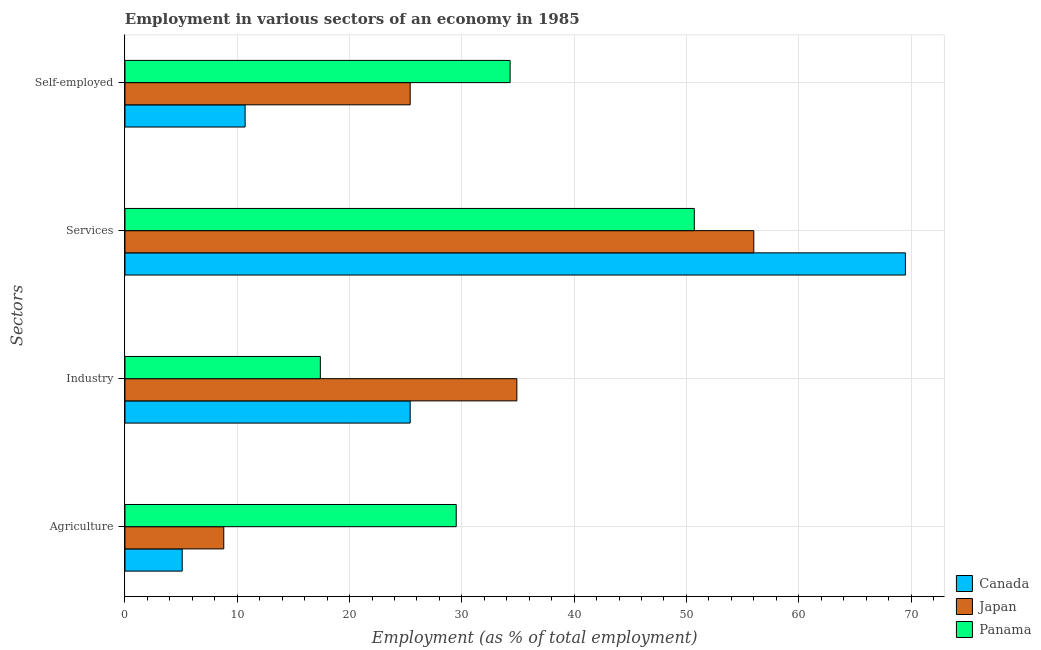How many different coloured bars are there?
Offer a terse response. 3. How many groups of bars are there?
Your response must be concise. 4. How many bars are there on the 1st tick from the bottom?
Offer a terse response. 3. What is the label of the 2nd group of bars from the top?
Give a very brief answer. Services. What is the percentage of self employed workers in Japan?
Give a very brief answer. 25.4. Across all countries, what is the maximum percentage of self employed workers?
Your answer should be very brief. 34.3. Across all countries, what is the minimum percentage of self employed workers?
Provide a succinct answer. 10.7. In which country was the percentage of workers in services maximum?
Make the answer very short. Canada. In which country was the percentage of workers in services minimum?
Keep it short and to the point. Panama. What is the total percentage of workers in industry in the graph?
Keep it short and to the point. 77.7. What is the difference between the percentage of workers in industry in Panama and that in Japan?
Keep it short and to the point. -17.5. What is the difference between the percentage of workers in agriculture in Canada and the percentage of self employed workers in Japan?
Offer a very short reply. -20.3. What is the average percentage of workers in industry per country?
Give a very brief answer. 25.9. What is the difference between the percentage of workers in services and percentage of workers in industry in Japan?
Provide a succinct answer. 21.1. What is the ratio of the percentage of self employed workers in Canada to that in Japan?
Make the answer very short. 0.42. What is the difference between the highest and the second highest percentage of self employed workers?
Keep it short and to the point. 8.9. What is the difference between the highest and the lowest percentage of workers in agriculture?
Ensure brevity in your answer.  24.4. In how many countries, is the percentage of self employed workers greater than the average percentage of self employed workers taken over all countries?
Provide a succinct answer. 2. Is the sum of the percentage of workers in agriculture in Canada and Japan greater than the maximum percentage of workers in services across all countries?
Your answer should be very brief. No. How many bars are there?
Provide a succinct answer. 12. How many countries are there in the graph?
Offer a terse response. 3. Are the values on the major ticks of X-axis written in scientific E-notation?
Your answer should be compact. No. Does the graph contain any zero values?
Your answer should be very brief. No. Does the graph contain grids?
Provide a succinct answer. Yes. What is the title of the graph?
Provide a succinct answer. Employment in various sectors of an economy in 1985. What is the label or title of the X-axis?
Your response must be concise. Employment (as % of total employment). What is the label or title of the Y-axis?
Your answer should be very brief. Sectors. What is the Employment (as % of total employment) of Canada in Agriculture?
Your response must be concise. 5.1. What is the Employment (as % of total employment) of Japan in Agriculture?
Keep it short and to the point. 8.8. What is the Employment (as % of total employment) in Panama in Agriculture?
Make the answer very short. 29.5. What is the Employment (as % of total employment) in Canada in Industry?
Offer a terse response. 25.4. What is the Employment (as % of total employment) in Japan in Industry?
Offer a terse response. 34.9. What is the Employment (as % of total employment) of Panama in Industry?
Ensure brevity in your answer.  17.4. What is the Employment (as % of total employment) in Canada in Services?
Make the answer very short. 69.5. What is the Employment (as % of total employment) of Japan in Services?
Offer a very short reply. 56. What is the Employment (as % of total employment) of Panama in Services?
Your response must be concise. 50.7. What is the Employment (as % of total employment) in Canada in Self-employed?
Keep it short and to the point. 10.7. What is the Employment (as % of total employment) in Japan in Self-employed?
Your answer should be very brief. 25.4. What is the Employment (as % of total employment) of Panama in Self-employed?
Ensure brevity in your answer.  34.3. Across all Sectors, what is the maximum Employment (as % of total employment) of Canada?
Give a very brief answer. 69.5. Across all Sectors, what is the maximum Employment (as % of total employment) of Japan?
Ensure brevity in your answer.  56. Across all Sectors, what is the maximum Employment (as % of total employment) of Panama?
Your answer should be compact. 50.7. Across all Sectors, what is the minimum Employment (as % of total employment) of Canada?
Offer a terse response. 5.1. Across all Sectors, what is the minimum Employment (as % of total employment) of Japan?
Give a very brief answer. 8.8. Across all Sectors, what is the minimum Employment (as % of total employment) of Panama?
Keep it short and to the point. 17.4. What is the total Employment (as % of total employment) in Canada in the graph?
Your response must be concise. 110.7. What is the total Employment (as % of total employment) of Japan in the graph?
Provide a short and direct response. 125.1. What is the total Employment (as % of total employment) of Panama in the graph?
Provide a succinct answer. 131.9. What is the difference between the Employment (as % of total employment) of Canada in Agriculture and that in Industry?
Provide a short and direct response. -20.3. What is the difference between the Employment (as % of total employment) of Japan in Agriculture and that in Industry?
Offer a terse response. -26.1. What is the difference between the Employment (as % of total employment) of Panama in Agriculture and that in Industry?
Offer a terse response. 12.1. What is the difference between the Employment (as % of total employment) in Canada in Agriculture and that in Services?
Offer a very short reply. -64.4. What is the difference between the Employment (as % of total employment) in Japan in Agriculture and that in Services?
Ensure brevity in your answer.  -47.2. What is the difference between the Employment (as % of total employment) in Panama in Agriculture and that in Services?
Make the answer very short. -21.2. What is the difference between the Employment (as % of total employment) of Canada in Agriculture and that in Self-employed?
Give a very brief answer. -5.6. What is the difference between the Employment (as % of total employment) in Japan in Agriculture and that in Self-employed?
Provide a succinct answer. -16.6. What is the difference between the Employment (as % of total employment) of Canada in Industry and that in Services?
Give a very brief answer. -44.1. What is the difference between the Employment (as % of total employment) of Japan in Industry and that in Services?
Your answer should be very brief. -21.1. What is the difference between the Employment (as % of total employment) in Panama in Industry and that in Services?
Ensure brevity in your answer.  -33.3. What is the difference between the Employment (as % of total employment) in Canada in Industry and that in Self-employed?
Provide a short and direct response. 14.7. What is the difference between the Employment (as % of total employment) in Panama in Industry and that in Self-employed?
Give a very brief answer. -16.9. What is the difference between the Employment (as % of total employment) of Canada in Services and that in Self-employed?
Your answer should be compact. 58.8. What is the difference between the Employment (as % of total employment) of Japan in Services and that in Self-employed?
Your response must be concise. 30.6. What is the difference between the Employment (as % of total employment) of Panama in Services and that in Self-employed?
Provide a short and direct response. 16.4. What is the difference between the Employment (as % of total employment) of Canada in Agriculture and the Employment (as % of total employment) of Japan in Industry?
Keep it short and to the point. -29.8. What is the difference between the Employment (as % of total employment) in Canada in Agriculture and the Employment (as % of total employment) in Panama in Industry?
Your answer should be compact. -12.3. What is the difference between the Employment (as % of total employment) of Japan in Agriculture and the Employment (as % of total employment) of Panama in Industry?
Give a very brief answer. -8.6. What is the difference between the Employment (as % of total employment) of Canada in Agriculture and the Employment (as % of total employment) of Japan in Services?
Offer a terse response. -50.9. What is the difference between the Employment (as % of total employment) of Canada in Agriculture and the Employment (as % of total employment) of Panama in Services?
Give a very brief answer. -45.6. What is the difference between the Employment (as % of total employment) in Japan in Agriculture and the Employment (as % of total employment) in Panama in Services?
Offer a very short reply. -41.9. What is the difference between the Employment (as % of total employment) in Canada in Agriculture and the Employment (as % of total employment) in Japan in Self-employed?
Your answer should be compact. -20.3. What is the difference between the Employment (as % of total employment) in Canada in Agriculture and the Employment (as % of total employment) in Panama in Self-employed?
Your response must be concise. -29.2. What is the difference between the Employment (as % of total employment) in Japan in Agriculture and the Employment (as % of total employment) in Panama in Self-employed?
Provide a short and direct response. -25.5. What is the difference between the Employment (as % of total employment) in Canada in Industry and the Employment (as % of total employment) in Japan in Services?
Provide a short and direct response. -30.6. What is the difference between the Employment (as % of total employment) in Canada in Industry and the Employment (as % of total employment) in Panama in Services?
Keep it short and to the point. -25.3. What is the difference between the Employment (as % of total employment) of Japan in Industry and the Employment (as % of total employment) of Panama in Services?
Your answer should be compact. -15.8. What is the difference between the Employment (as % of total employment) of Canada in Industry and the Employment (as % of total employment) of Japan in Self-employed?
Keep it short and to the point. 0. What is the difference between the Employment (as % of total employment) of Japan in Industry and the Employment (as % of total employment) of Panama in Self-employed?
Provide a short and direct response. 0.6. What is the difference between the Employment (as % of total employment) in Canada in Services and the Employment (as % of total employment) in Japan in Self-employed?
Your answer should be very brief. 44.1. What is the difference between the Employment (as % of total employment) of Canada in Services and the Employment (as % of total employment) of Panama in Self-employed?
Your answer should be very brief. 35.2. What is the difference between the Employment (as % of total employment) in Japan in Services and the Employment (as % of total employment) in Panama in Self-employed?
Your answer should be very brief. 21.7. What is the average Employment (as % of total employment) in Canada per Sectors?
Make the answer very short. 27.68. What is the average Employment (as % of total employment) of Japan per Sectors?
Give a very brief answer. 31.27. What is the average Employment (as % of total employment) in Panama per Sectors?
Your answer should be compact. 32.98. What is the difference between the Employment (as % of total employment) in Canada and Employment (as % of total employment) in Japan in Agriculture?
Give a very brief answer. -3.7. What is the difference between the Employment (as % of total employment) of Canada and Employment (as % of total employment) of Panama in Agriculture?
Your answer should be very brief. -24.4. What is the difference between the Employment (as % of total employment) of Japan and Employment (as % of total employment) of Panama in Agriculture?
Provide a short and direct response. -20.7. What is the difference between the Employment (as % of total employment) in Canada and Employment (as % of total employment) in Japan in Industry?
Keep it short and to the point. -9.5. What is the difference between the Employment (as % of total employment) of Canada and Employment (as % of total employment) of Japan in Services?
Offer a very short reply. 13.5. What is the difference between the Employment (as % of total employment) in Canada and Employment (as % of total employment) in Panama in Services?
Keep it short and to the point. 18.8. What is the difference between the Employment (as % of total employment) in Canada and Employment (as % of total employment) in Japan in Self-employed?
Give a very brief answer. -14.7. What is the difference between the Employment (as % of total employment) of Canada and Employment (as % of total employment) of Panama in Self-employed?
Offer a very short reply. -23.6. What is the difference between the Employment (as % of total employment) in Japan and Employment (as % of total employment) in Panama in Self-employed?
Give a very brief answer. -8.9. What is the ratio of the Employment (as % of total employment) in Canada in Agriculture to that in Industry?
Your response must be concise. 0.2. What is the ratio of the Employment (as % of total employment) in Japan in Agriculture to that in Industry?
Give a very brief answer. 0.25. What is the ratio of the Employment (as % of total employment) in Panama in Agriculture to that in Industry?
Your answer should be compact. 1.7. What is the ratio of the Employment (as % of total employment) in Canada in Agriculture to that in Services?
Offer a terse response. 0.07. What is the ratio of the Employment (as % of total employment) in Japan in Agriculture to that in Services?
Make the answer very short. 0.16. What is the ratio of the Employment (as % of total employment) in Panama in Agriculture to that in Services?
Your answer should be very brief. 0.58. What is the ratio of the Employment (as % of total employment) in Canada in Agriculture to that in Self-employed?
Provide a short and direct response. 0.48. What is the ratio of the Employment (as % of total employment) of Japan in Agriculture to that in Self-employed?
Provide a succinct answer. 0.35. What is the ratio of the Employment (as % of total employment) of Panama in Agriculture to that in Self-employed?
Your answer should be very brief. 0.86. What is the ratio of the Employment (as % of total employment) in Canada in Industry to that in Services?
Ensure brevity in your answer.  0.37. What is the ratio of the Employment (as % of total employment) in Japan in Industry to that in Services?
Give a very brief answer. 0.62. What is the ratio of the Employment (as % of total employment) of Panama in Industry to that in Services?
Your answer should be very brief. 0.34. What is the ratio of the Employment (as % of total employment) of Canada in Industry to that in Self-employed?
Make the answer very short. 2.37. What is the ratio of the Employment (as % of total employment) in Japan in Industry to that in Self-employed?
Your answer should be compact. 1.37. What is the ratio of the Employment (as % of total employment) in Panama in Industry to that in Self-employed?
Offer a very short reply. 0.51. What is the ratio of the Employment (as % of total employment) in Canada in Services to that in Self-employed?
Your response must be concise. 6.5. What is the ratio of the Employment (as % of total employment) of Japan in Services to that in Self-employed?
Your answer should be compact. 2.2. What is the ratio of the Employment (as % of total employment) in Panama in Services to that in Self-employed?
Keep it short and to the point. 1.48. What is the difference between the highest and the second highest Employment (as % of total employment) in Canada?
Your answer should be compact. 44.1. What is the difference between the highest and the second highest Employment (as % of total employment) in Japan?
Make the answer very short. 21.1. What is the difference between the highest and the lowest Employment (as % of total employment) in Canada?
Provide a short and direct response. 64.4. What is the difference between the highest and the lowest Employment (as % of total employment) in Japan?
Offer a very short reply. 47.2. What is the difference between the highest and the lowest Employment (as % of total employment) in Panama?
Ensure brevity in your answer.  33.3. 